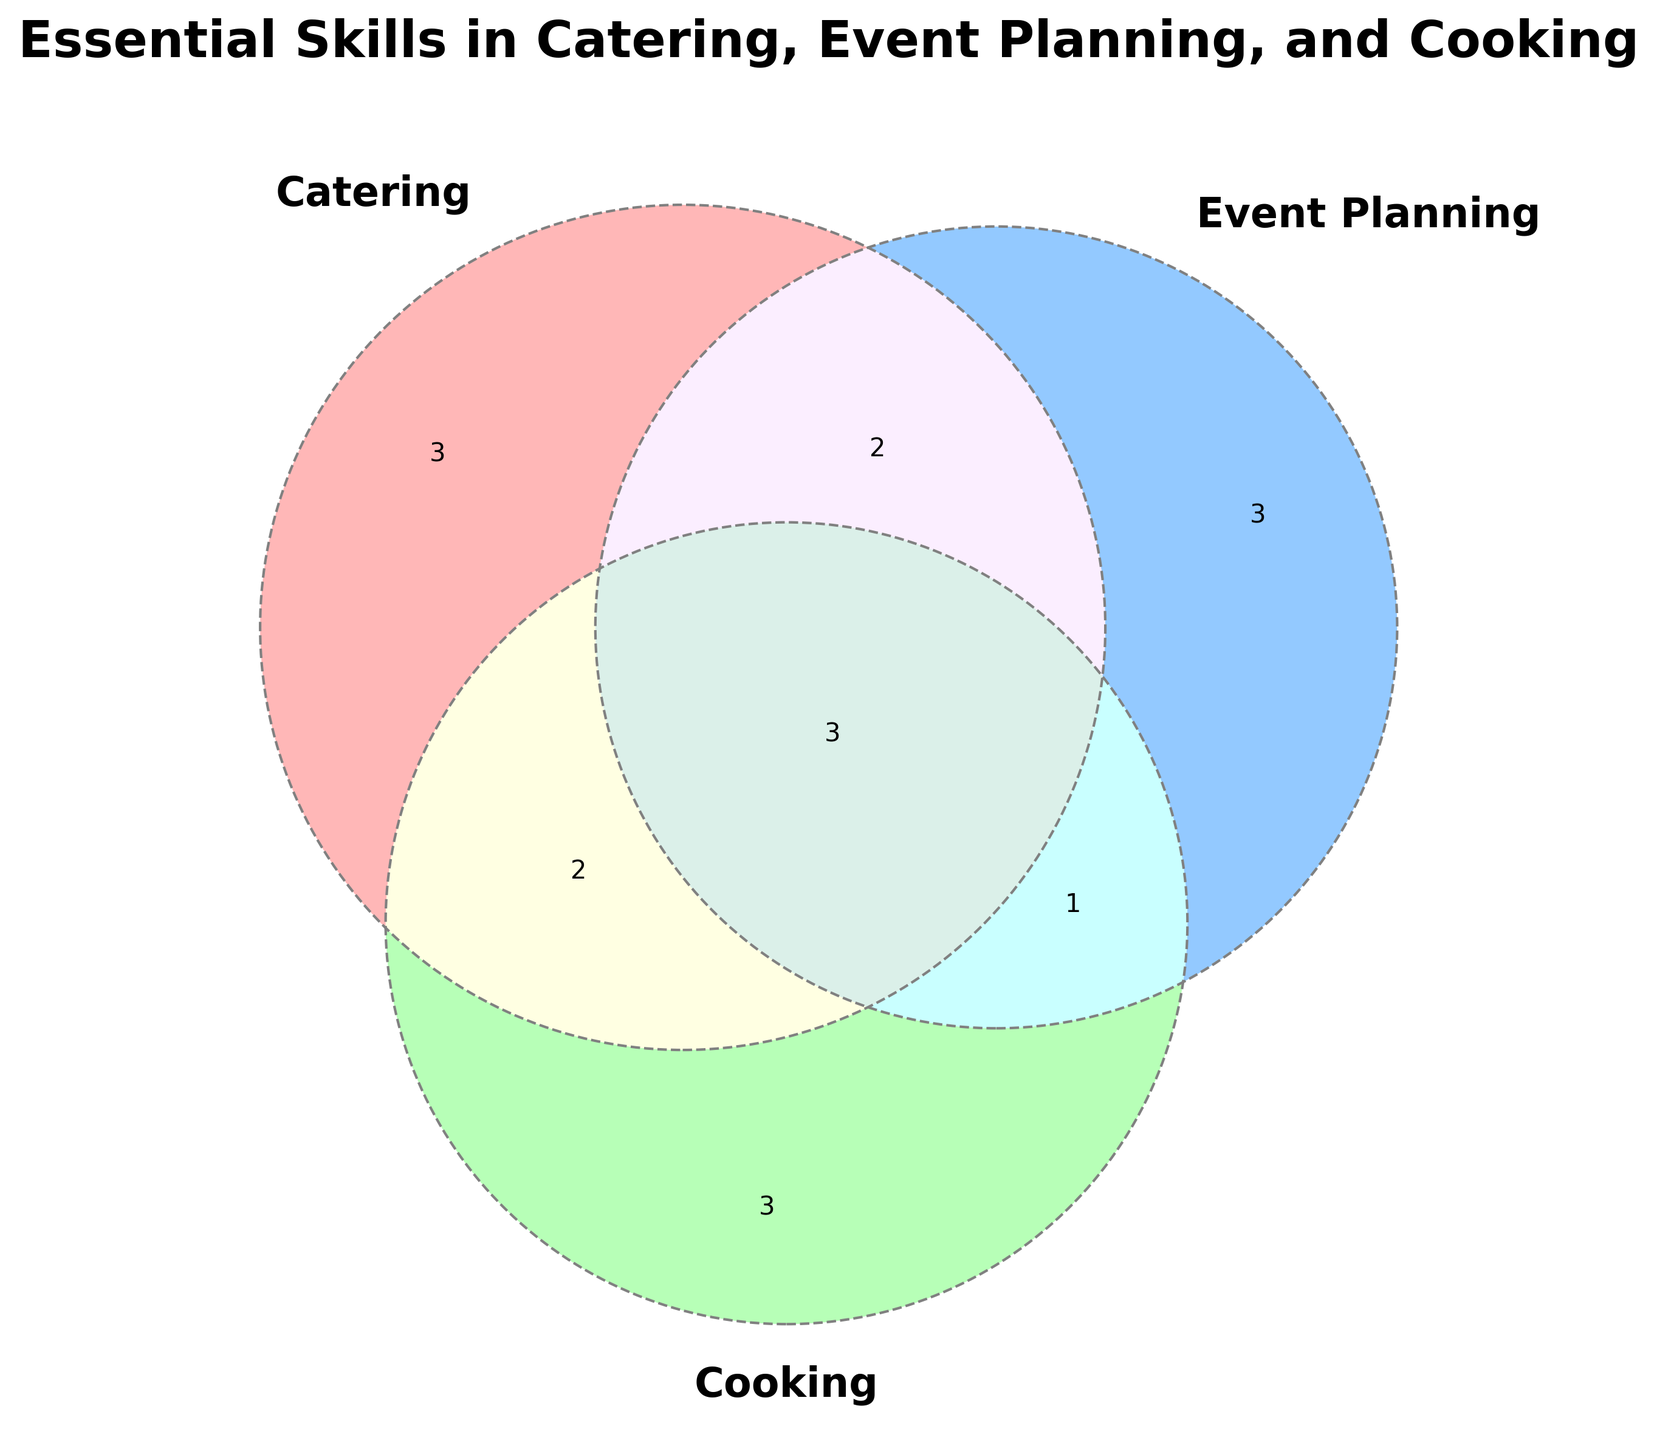What is the title of the Venn Diagram? The title is displayed at the top of the diagram and summarizes what the figure is about.
Answer: Essential Skills in Catering, Event Planning, and Cooking Which skill is common to all three categories: Catering, Event Planning, and Cooking? Find the skill in the intersection area where all three circles overlap.
Answer: Multitasking Name a skill that is unique to Event Planning. Look at the section where only the Event Planning circle appears without overlapping with others.
Answer: Vendor coordination How many skills are shared between Catering and Cooking but not Event Planning? Check the overlapping area of Catering and Cooking circles that does not intersect with the Event Planning circle.
Answer: 2 (Dietary restrictions, Food sourcing) Which category has the skill "Timeline management"? Find the skill within the circles and see which category it belongs to.
Answer: Event Planning How many skills are exclusive to Catering? Count the number of skills in the section where only the Catering circle appears without overlapping with others.
Answer: 3 (Menu planning, Food safety, Portion control) Which category shares the skill "Client communication" with Catering? Look for the other circle overlapping with Catering that includes the skill "Client communication".
Answer: Event Planning Is "Problem-solving" specific to any one category? Check if "Problem-solving" lies in any single section of the Venn Diagram.
Answer: No, it is common to all three categories What are the common skills between Catering and Event Planning? Identify the skills in the intersection area between Catering and Event Planning circles.
Answer: Client communication, Logistics Which skill belongs to both Event Planning and Cooking but not Catering? Look at the overlapping area of Event Planning and Cooking circles excluding the Catering circle.
Answer: Theme integration 